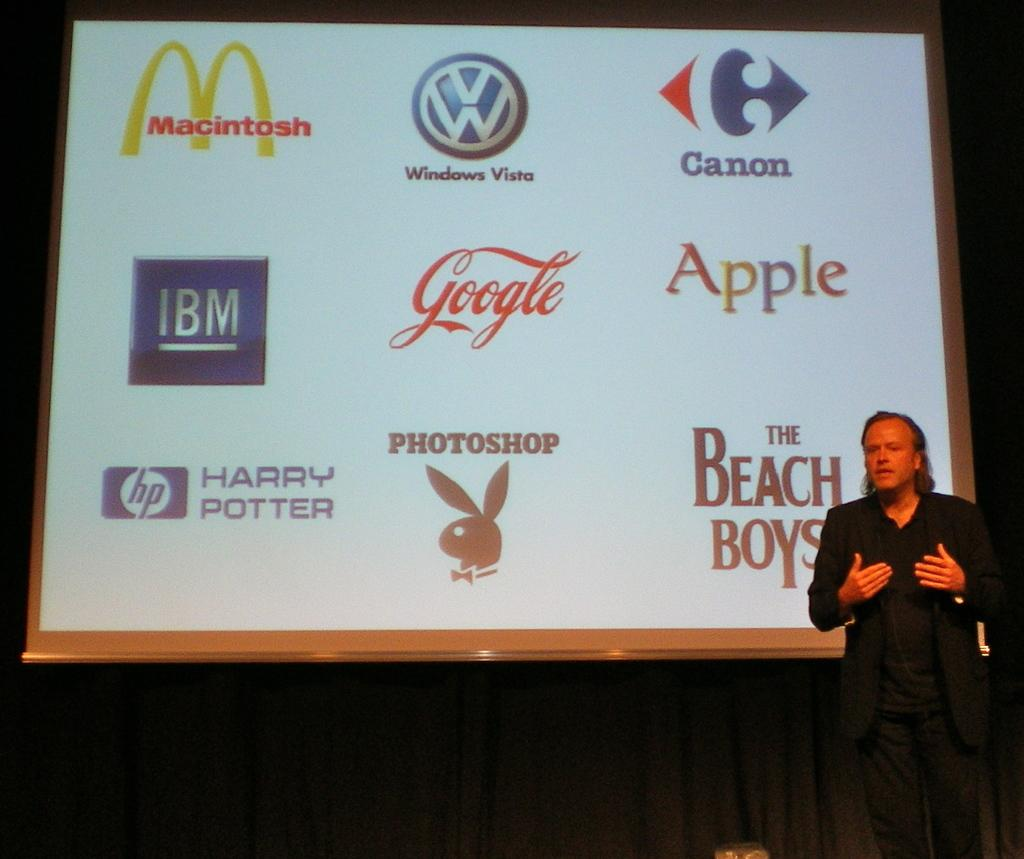What is the person on the right side of the image wearing? The person is wearing a black color dress. What is the person doing in the image? The person is standing and speaking. What can be seen in the background of the image? There is a screen arranged in the background of the image. How would you describe the overall color scheme of the background? The background is dark in color. What type of machine is being used by the person to lose weight in the image? There is no machine or indication of weight loss in the image; the person is simply standing and speaking. Can you see a zipper on the person's dress in the image? There is no visible zipper on the person's dress in the image. 